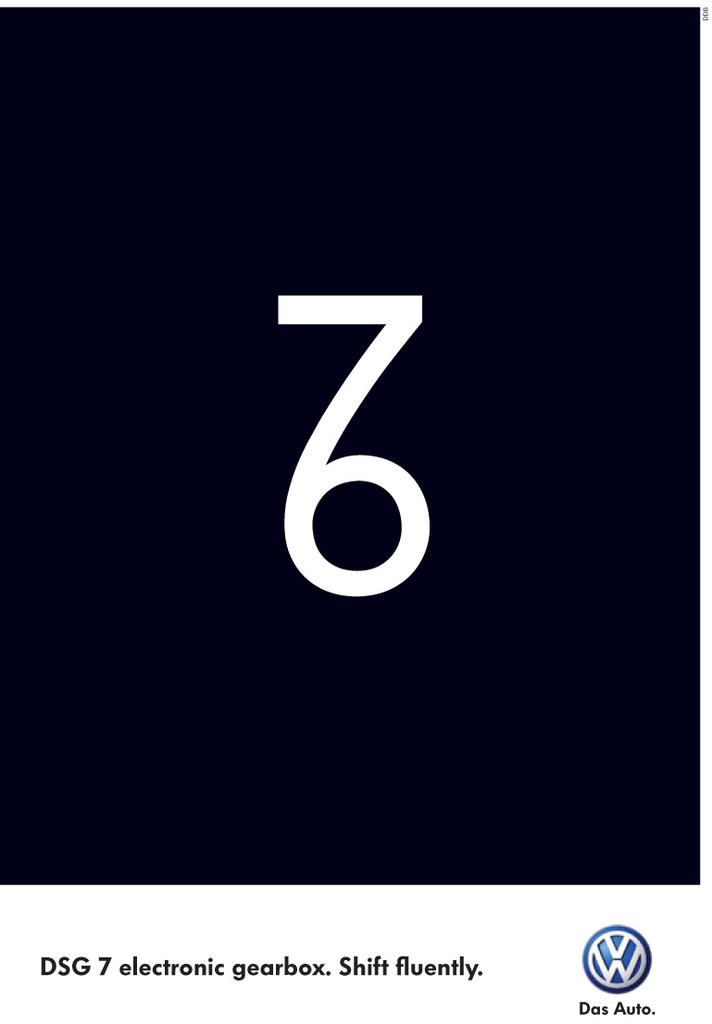<image>
Provide a brief description of the given image. A Volkswagen advertisement features the number 76 intertwined together. 